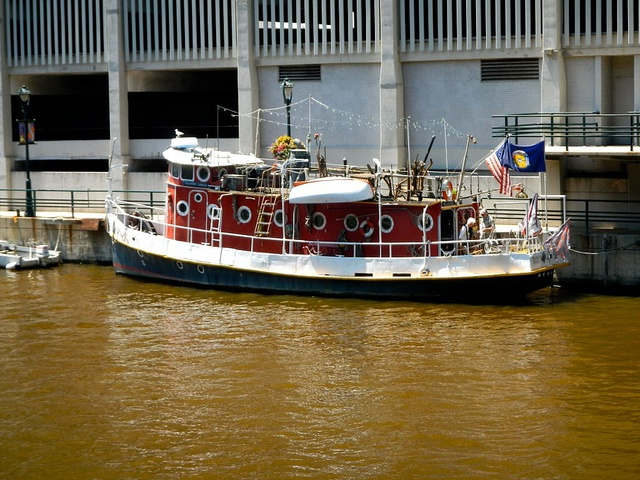Describe the objects in this image and their specific colors. I can see boat in gray, black, darkgray, white, and maroon tones, people in gray, ivory, darkgray, and maroon tones, and people in gray, black, darkgray, and lightgray tones in this image. 